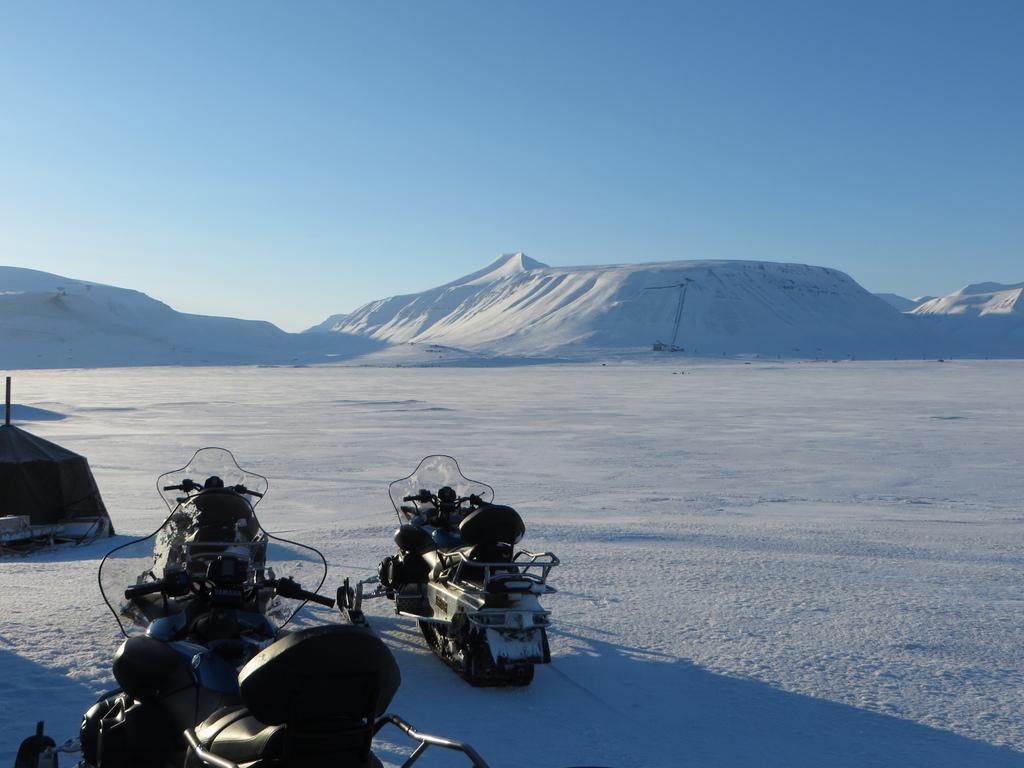Can you describe this image briefly? On the left there are vehicles. In this picture there is snow. In the center of the picture there are hills covered with snow. Sky is sunny. 